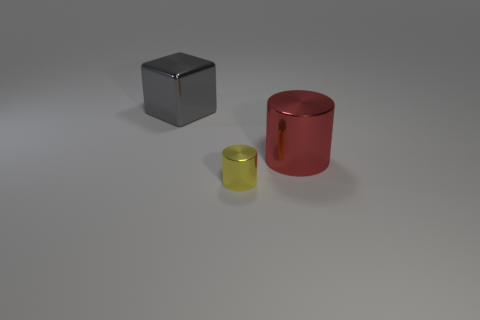Add 2 big red metallic cylinders. How many objects exist? 5 Subtract all cubes. How many objects are left? 2 Subtract all large gray metal objects. Subtract all tiny shiny cylinders. How many objects are left? 1 Add 1 tiny yellow objects. How many tiny yellow objects are left? 2 Add 2 purple rubber cylinders. How many purple rubber cylinders exist? 2 Subtract 1 gray blocks. How many objects are left? 2 